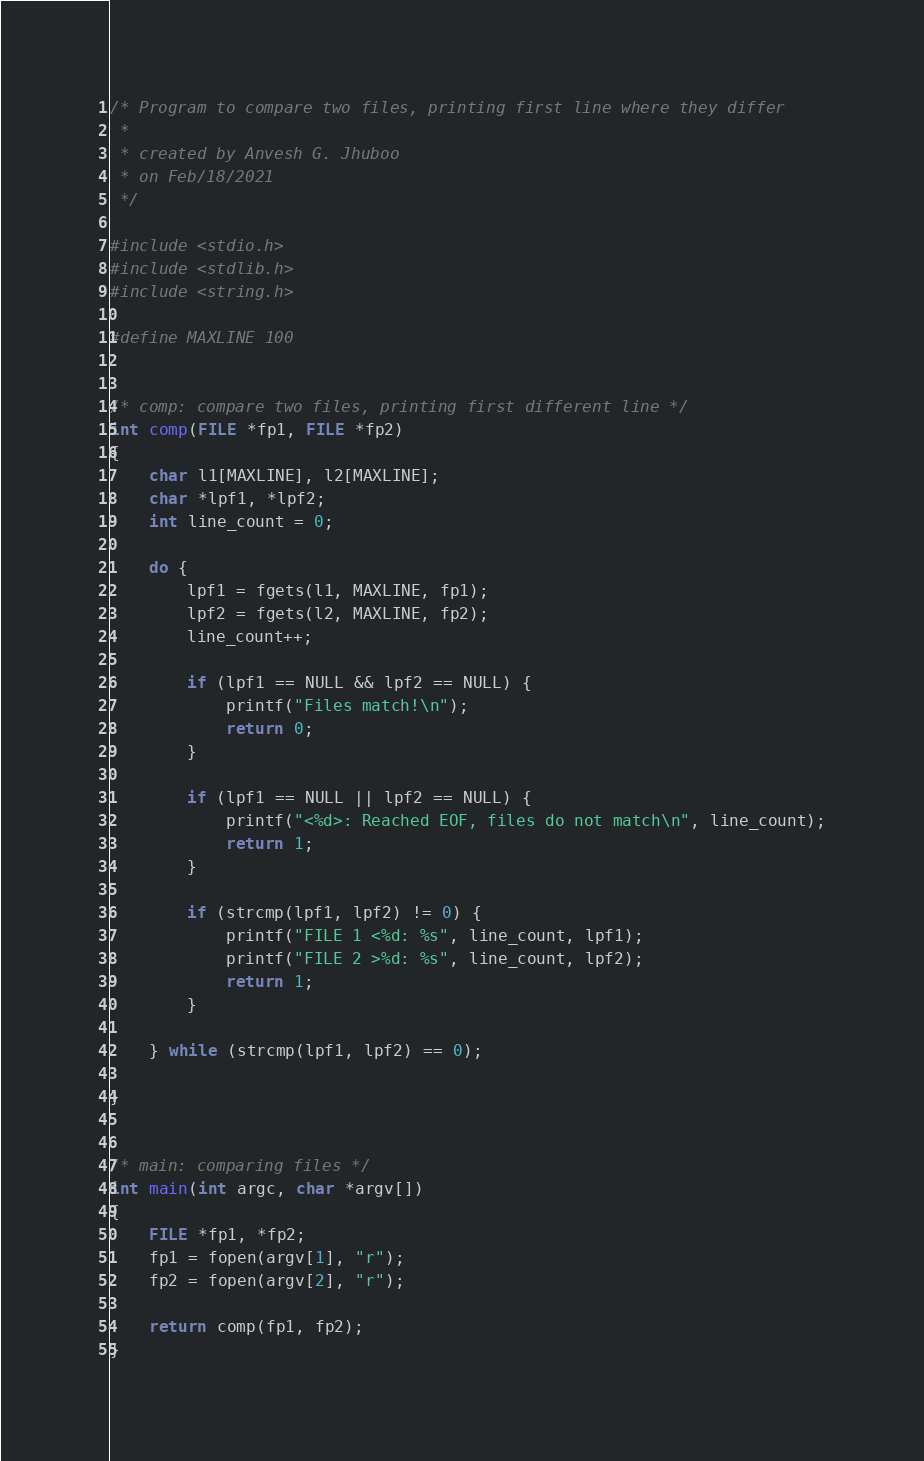<code> <loc_0><loc_0><loc_500><loc_500><_C_>/* Program to compare two files, printing first line where they differ
 *
 * created by Anvesh G. Jhuboo
 * on Feb/18/2021
 */

#include <stdio.h>
#include <stdlib.h>
#include <string.h>

#define MAXLINE 100


/* comp: compare two files, printing first different line */
int comp(FILE *fp1, FILE *fp2)
{
    char l1[MAXLINE], l2[MAXLINE];
    char *lpf1, *lpf2;
    int line_count = 0;

    do {
        lpf1 = fgets(l1, MAXLINE, fp1);
        lpf2 = fgets(l2, MAXLINE, fp2);
        line_count++;

        if (lpf1 == NULL && lpf2 == NULL) {
            printf("Files match!\n");
            return 0;
        }

        if (lpf1 == NULL || lpf2 == NULL) {
            printf("<%d>: Reached EOF, files do not match\n", line_count);
            return 1;
        }

        if (strcmp(lpf1, lpf2) != 0) {
            printf("FILE 1 <%d: %s", line_count, lpf1);
            printf("FILE 2 >%d: %s", line_count, lpf2);
            return 1;
        }

    } while (strcmp(lpf1, lpf2) == 0);
    
}


/* main: comparing files */
int main(int argc, char *argv[])
{
    FILE *fp1, *fp2;
    fp1 = fopen(argv[1], "r");
    fp2 = fopen(argv[2], "r");

    return comp(fp1, fp2);
}
</code> 